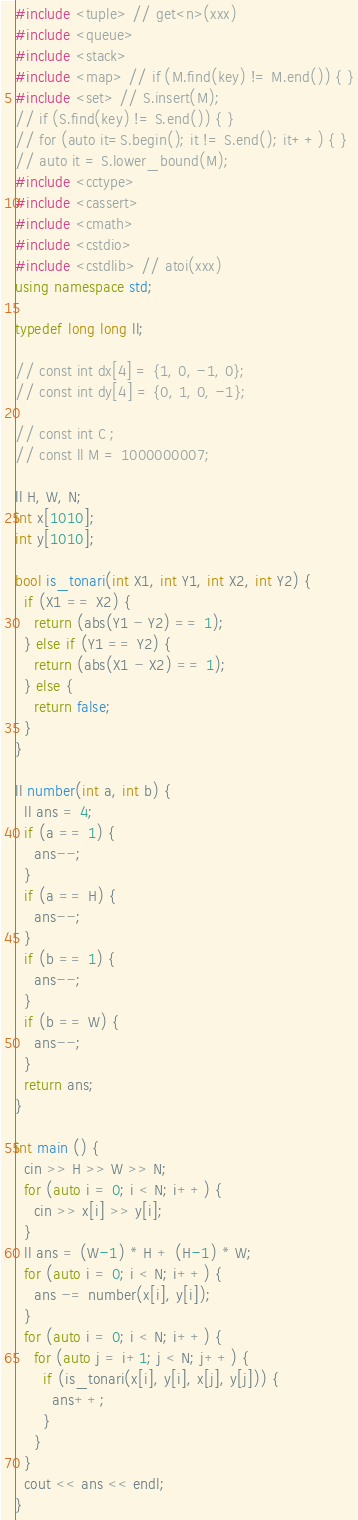Convert code to text. <code><loc_0><loc_0><loc_500><loc_500><_C++_>#include <tuple> // get<n>(xxx)
#include <queue>
#include <stack>
#include <map> // if (M.find(key) != M.end()) { }
#include <set> // S.insert(M);
// if (S.find(key) != S.end()) { }
// for (auto it=S.begin(); it != S.end(); it++) { }
// auto it = S.lower_bound(M);
#include <cctype>
#include <cassert>
#include <cmath>
#include <cstdio>
#include <cstdlib> // atoi(xxx)
using namespace std;

typedef long long ll;

// const int dx[4] = {1, 0, -1, 0};
// const int dy[4] = {0, 1, 0, -1};

// const int C ;
// const ll M = 1000000007;

ll H, W, N;
int x[1010];
int y[1010];

bool is_tonari(int X1, int Y1, int X2, int Y2) {
  if (X1 == X2) {
    return (abs(Y1 - Y2) == 1);
  } else if (Y1 == Y2) {
    return (abs(X1 - X2) == 1);    
  } else {
    return false;
  }
}

ll number(int a, int b) {
  ll ans = 4;
  if (a == 1) {
    ans--;
  }
  if (a == H) {
    ans--;
  }
  if (b == 1) {
    ans--;
  }
  if (b == W) {
    ans--;
  }
  return ans;
}

int main () {
  cin >> H >> W >> N;
  for (auto i = 0; i < N; i++) {
    cin >> x[i] >> y[i];
  }
  ll ans = (W-1) * H + (H-1) * W;
  for (auto i = 0; i < N; i++) {
    ans -= number(x[i], y[i]);
  }
  for (auto i = 0; i < N; i++) {
    for (auto j = i+1; j < N; j++) {
      if (is_tonari(x[i], y[i], x[j], y[j])) {
        ans++;
      }
    }
  }
  cout << ans << endl;
}
</code> 